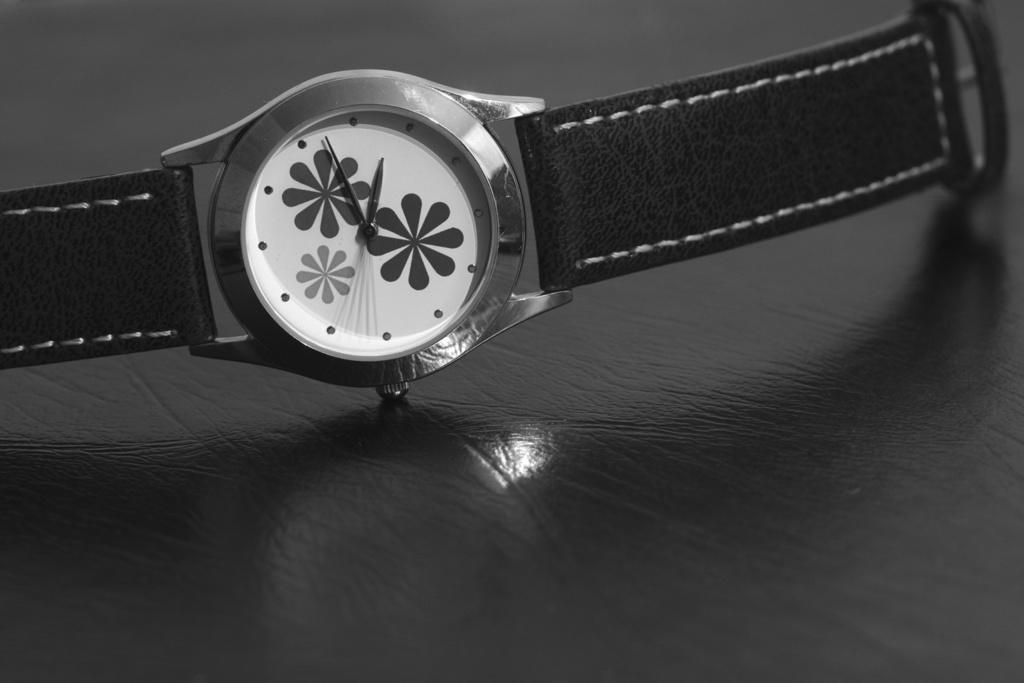How would you summarize this image in a sentence or two? In this picture we can see one watch is placed on the surface. 